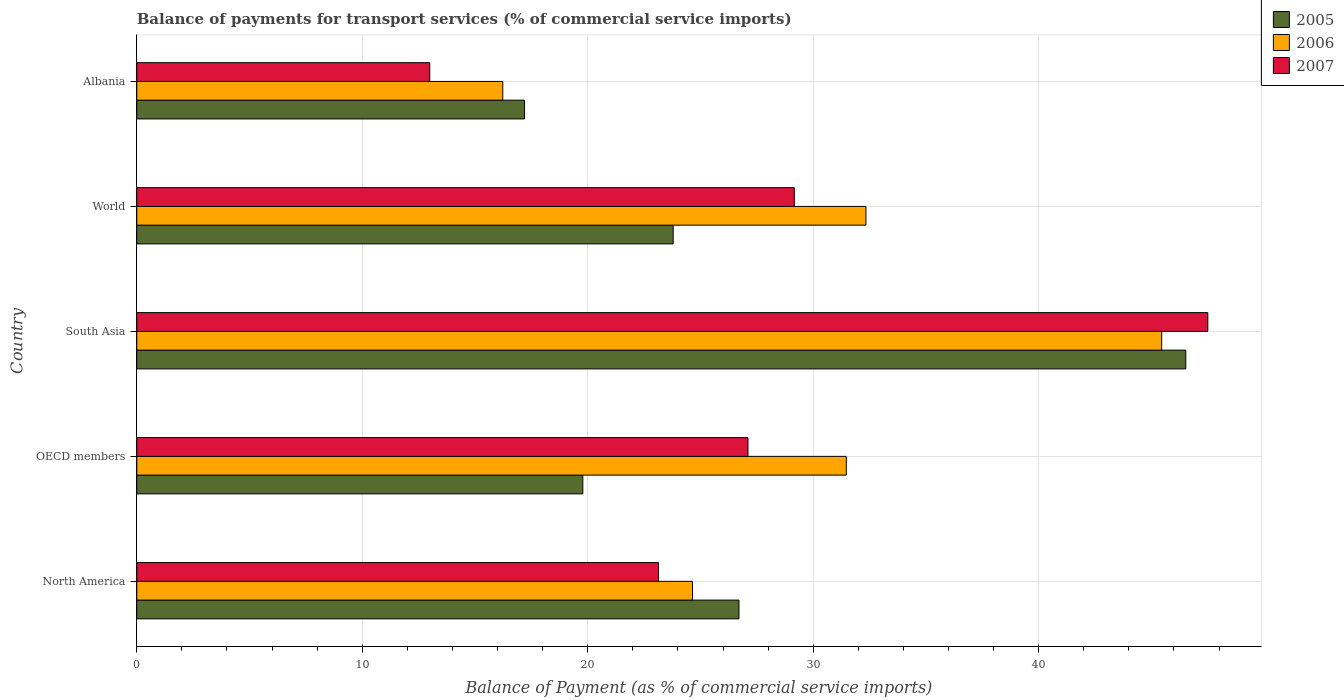How many different coloured bars are there?
Your answer should be very brief. 3. How many groups of bars are there?
Your answer should be compact. 5. Are the number of bars on each tick of the Y-axis equal?
Your answer should be compact. Yes. In how many cases, is the number of bars for a given country not equal to the number of legend labels?
Offer a very short reply. 0. What is the balance of payments for transport services in 2007 in Albania?
Provide a succinct answer. 12.99. Across all countries, what is the maximum balance of payments for transport services in 2007?
Offer a terse response. 47.5. Across all countries, what is the minimum balance of payments for transport services in 2005?
Provide a succinct answer. 17.2. In which country was the balance of payments for transport services in 2005 maximum?
Offer a terse response. South Asia. In which country was the balance of payments for transport services in 2007 minimum?
Provide a succinct answer. Albania. What is the total balance of payments for transport services in 2006 in the graph?
Provide a succinct answer. 150.14. What is the difference between the balance of payments for transport services in 2007 in OECD members and that in South Asia?
Your response must be concise. -20.39. What is the difference between the balance of payments for transport services in 2005 in Albania and the balance of payments for transport services in 2006 in World?
Ensure brevity in your answer.  -15.14. What is the average balance of payments for transport services in 2007 per country?
Provide a short and direct response. 27.98. What is the difference between the balance of payments for transport services in 2007 and balance of payments for transport services in 2005 in World?
Your response must be concise. 5.37. In how many countries, is the balance of payments for transport services in 2006 greater than 32 %?
Ensure brevity in your answer.  2. What is the ratio of the balance of payments for transport services in 2006 in OECD members to that in World?
Make the answer very short. 0.97. Is the difference between the balance of payments for transport services in 2007 in Albania and World greater than the difference between the balance of payments for transport services in 2005 in Albania and World?
Your answer should be compact. No. What is the difference between the highest and the second highest balance of payments for transport services in 2007?
Offer a terse response. 18.34. What is the difference between the highest and the lowest balance of payments for transport services in 2007?
Give a very brief answer. 34.51. Is the sum of the balance of payments for transport services in 2006 in South Asia and World greater than the maximum balance of payments for transport services in 2007 across all countries?
Offer a terse response. Yes. What does the 3rd bar from the bottom in World represents?
Offer a terse response. 2007. Is it the case that in every country, the sum of the balance of payments for transport services in 2006 and balance of payments for transport services in 2007 is greater than the balance of payments for transport services in 2005?
Provide a short and direct response. Yes. Are all the bars in the graph horizontal?
Your answer should be compact. Yes. Are the values on the major ticks of X-axis written in scientific E-notation?
Offer a very short reply. No. Does the graph contain any zero values?
Offer a very short reply. No. Does the graph contain grids?
Offer a very short reply. Yes. How are the legend labels stacked?
Your answer should be very brief. Vertical. What is the title of the graph?
Ensure brevity in your answer.  Balance of payments for transport services (% of commercial service imports). Does "1973" appear as one of the legend labels in the graph?
Your response must be concise. No. What is the label or title of the X-axis?
Keep it short and to the point. Balance of Payment (as % of commercial service imports). What is the Balance of Payment (as % of commercial service imports) in 2005 in North America?
Offer a very short reply. 26.71. What is the Balance of Payment (as % of commercial service imports) of 2006 in North America?
Provide a succinct answer. 24.65. What is the Balance of Payment (as % of commercial service imports) of 2007 in North America?
Your answer should be compact. 23.14. What is the Balance of Payment (as % of commercial service imports) in 2005 in OECD members?
Keep it short and to the point. 19.78. What is the Balance of Payment (as % of commercial service imports) of 2006 in OECD members?
Provide a succinct answer. 31.47. What is the Balance of Payment (as % of commercial service imports) in 2007 in OECD members?
Make the answer very short. 27.11. What is the Balance of Payment (as % of commercial service imports) in 2005 in South Asia?
Offer a terse response. 46.53. What is the Balance of Payment (as % of commercial service imports) in 2006 in South Asia?
Ensure brevity in your answer.  45.46. What is the Balance of Payment (as % of commercial service imports) of 2007 in South Asia?
Ensure brevity in your answer.  47.5. What is the Balance of Payment (as % of commercial service imports) in 2005 in World?
Offer a terse response. 23.79. What is the Balance of Payment (as % of commercial service imports) in 2006 in World?
Your response must be concise. 32.34. What is the Balance of Payment (as % of commercial service imports) of 2007 in World?
Ensure brevity in your answer.  29.16. What is the Balance of Payment (as % of commercial service imports) of 2005 in Albania?
Ensure brevity in your answer.  17.2. What is the Balance of Payment (as % of commercial service imports) in 2006 in Albania?
Offer a very short reply. 16.23. What is the Balance of Payment (as % of commercial service imports) in 2007 in Albania?
Offer a terse response. 12.99. Across all countries, what is the maximum Balance of Payment (as % of commercial service imports) in 2005?
Provide a short and direct response. 46.53. Across all countries, what is the maximum Balance of Payment (as % of commercial service imports) in 2006?
Offer a very short reply. 45.46. Across all countries, what is the maximum Balance of Payment (as % of commercial service imports) in 2007?
Offer a very short reply. 47.5. Across all countries, what is the minimum Balance of Payment (as % of commercial service imports) of 2005?
Your answer should be compact. 17.2. Across all countries, what is the minimum Balance of Payment (as % of commercial service imports) in 2006?
Offer a very short reply. 16.23. Across all countries, what is the minimum Balance of Payment (as % of commercial service imports) of 2007?
Keep it short and to the point. 12.99. What is the total Balance of Payment (as % of commercial service imports) of 2005 in the graph?
Your answer should be compact. 134. What is the total Balance of Payment (as % of commercial service imports) of 2006 in the graph?
Make the answer very short. 150.14. What is the total Balance of Payment (as % of commercial service imports) in 2007 in the graph?
Provide a short and direct response. 139.9. What is the difference between the Balance of Payment (as % of commercial service imports) of 2005 in North America and that in OECD members?
Ensure brevity in your answer.  6.93. What is the difference between the Balance of Payment (as % of commercial service imports) of 2006 in North America and that in OECD members?
Ensure brevity in your answer.  -6.82. What is the difference between the Balance of Payment (as % of commercial service imports) of 2007 in North America and that in OECD members?
Your answer should be very brief. -3.97. What is the difference between the Balance of Payment (as % of commercial service imports) in 2005 in North America and that in South Asia?
Your answer should be compact. -19.82. What is the difference between the Balance of Payment (as % of commercial service imports) in 2006 in North America and that in South Asia?
Provide a short and direct response. -20.81. What is the difference between the Balance of Payment (as % of commercial service imports) of 2007 in North America and that in South Asia?
Provide a succinct answer. -24.36. What is the difference between the Balance of Payment (as % of commercial service imports) in 2005 in North America and that in World?
Give a very brief answer. 2.92. What is the difference between the Balance of Payment (as % of commercial service imports) in 2006 in North America and that in World?
Provide a short and direct response. -7.69. What is the difference between the Balance of Payment (as % of commercial service imports) in 2007 in North America and that in World?
Make the answer very short. -6.02. What is the difference between the Balance of Payment (as % of commercial service imports) of 2005 in North America and that in Albania?
Provide a short and direct response. 9.51. What is the difference between the Balance of Payment (as % of commercial service imports) in 2006 in North America and that in Albania?
Offer a terse response. 8.41. What is the difference between the Balance of Payment (as % of commercial service imports) in 2007 in North America and that in Albania?
Provide a succinct answer. 10.15. What is the difference between the Balance of Payment (as % of commercial service imports) in 2005 in OECD members and that in South Asia?
Provide a short and direct response. -26.74. What is the difference between the Balance of Payment (as % of commercial service imports) in 2006 in OECD members and that in South Asia?
Your answer should be compact. -13.99. What is the difference between the Balance of Payment (as % of commercial service imports) of 2007 in OECD members and that in South Asia?
Keep it short and to the point. -20.39. What is the difference between the Balance of Payment (as % of commercial service imports) in 2005 in OECD members and that in World?
Provide a succinct answer. -4.01. What is the difference between the Balance of Payment (as % of commercial service imports) in 2006 in OECD members and that in World?
Make the answer very short. -0.87. What is the difference between the Balance of Payment (as % of commercial service imports) in 2007 in OECD members and that in World?
Provide a succinct answer. -2.05. What is the difference between the Balance of Payment (as % of commercial service imports) of 2005 in OECD members and that in Albania?
Offer a very short reply. 2.58. What is the difference between the Balance of Payment (as % of commercial service imports) of 2006 in OECD members and that in Albania?
Offer a very short reply. 15.24. What is the difference between the Balance of Payment (as % of commercial service imports) of 2007 in OECD members and that in Albania?
Your answer should be very brief. 14.11. What is the difference between the Balance of Payment (as % of commercial service imports) in 2005 in South Asia and that in World?
Provide a succinct answer. 22.74. What is the difference between the Balance of Payment (as % of commercial service imports) of 2006 in South Asia and that in World?
Keep it short and to the point. 13.12. What is the difference between the Balance of Payment (as % of commercial service imports) of 2007 in South Asia and that in World?
Give a very brief answer. 18.34. What is the difference between the Balance of Payment (as % of commercial service imports) in 2005 in South Asia and that in Albania?
Your answer should be very brief. 29.33. What is the difference between the Balance of Payment (as % of commercial service imports) of 2006 in South Asia and that in Albania?
Give a very brief answer. 29.22. What is the difference between the Balance of Payment (as % of commercial service imports) of 2007 in South Asia and that in Albania?
Your response must be concise. 34.51. What is the difference between the Balance of Payment (as % of commercial service imports) of 2005 in World and that in Albania?
Your response must be concise. 6.59. What is the difference between the Balance of Payment (as % of commercial service imports) of 2006 in World and that in Albania?
Make the answer very short. 16.11. What is the difference between the Balance of Payment (as % of commercial service imports) of 2007 in World and that in Albania?
Give a very brief answer. 16.17. What is the difference between the Balance of Payment (as % of commercial service imports) in 2005 in North America and the Balance of Payment (as % of commercial service imports) in 2006 in OECD members?
Make the answer very short. -4.76. What is the difference between the Balance of Payment (as % of commercial service imports) in 2005 in North America and the Balance of Payment (as % of commercial service imports) in 2007 in OECD members?
Your answer should be compact. -0.4. What is the difference between the Balance of Payment (as % of commercial service imports) of 2006 in North America and the Balance of Payment (as % of commercial service imports) of 2007 in OECD members?
Your answer should be very brief. -2.46. What is the difference between the Balance of Payment (as % of commercial service imports) of 2005 in North America and the Balance of Payment (as % of commercial service imports) of 2006 in South Asia?
Give a very brief answer. -18.75. What is the difference between the Balance of Payment (as % of commercial service imports) of 2005 in North America and the Balance of Payment (as % of commercial service imports) of 2007 in South Asia?
Provide a short and direct response. -20.79. What is the difference between the Balance of Payment (as % of commercial service imports) in 2006 in North America and the Balance of Payment (as % of commercial service imports) in 2007 in South Asia?
Your response must be concise. -22.85. What is the difference between the Balance of Payment (as % of commercial service imports) in 2005 in North America and the Balance of Payment (as % of commercial service imports) in 2006 in World?
Ensure brevity in your answer.  -5.63. What is the difference between the Balance of Payment (as % of commercial service imports) in 2005 in North America and the Balance of Payment (as % of commercial service imports) in 2007 in World?
Offer a very short reply. -2.45. What is the difference between the Balance of Payment (as % of commercial service imports) of 2006 in North America and the Balance of Payment (as % of commercial service imports) of 2007 in World?
Your response must be concise. -4.51. What is the difference between the Balance of Payment (as % of commercial service imports) of 2005 in North America and the Balance of Payment (as % of commercial service imports) of 2006 in Albania?
Make the answer very short. 10.48. What is the difference between the Balance of Payment (as % of commercial service imports) in 2005 in North America and the Balance of Payment (as % of commercial service imports) in 2007 in Albania?
Keep it short and to the point. 13.71. What is the difference between the Balance of Payment (as % of commercial service imports) of 2006 in North America and the Balance of Payment (as % of commercial service imports) of 2007 in Albania?
Provide a succinct answer. 11.65. What is the difference between the Balance of Payment (as % of commercial service imports) in 2005 in OECD members and the Balance of Payment (as % of commercial service imports) in 2006 in South Asia?
Offer a very short reply. -25.67. What is the difference between the Balance of Payment (as % of commercial service imports) of 2005 in OECD members and the Balance of Payment (as % of commercial service imports) of 2007 in South Asia?
Provide a short and direct response. -27.72. What is the difference between the Balance of Payment (as % of commercial service imports) of 2006 in OECD members and the Balance of Payment (as % of commercial service imports) of 2007 in South Asia?
Your answer should be compact. -16.03. What is the difference between the Balance of Payment (as % of commercial service imports) in 2005 in OECD members and the Balance of Payment (as % of commercial service imports) in 2006 in World?
Provide a succinct answer. -12.56. What is the difference between the Balance of Payment (as % of commercial service imports) in 2005 in OECD members and the Balance of Payment (as % of commercial service imports) in 2007 in World?
Make the answer very short. -9.38. What is the difference between the Balance of Payment (as % of commercial service imports) in 2006 in OECD members and the Balance of Payment (as % of commercial service imports) in 2007 in World?
Offer a terse response. 2.31. What is the difference between the Balance of Payment (as % of commercial service imports) of 2005 in OECD members and the Balance of Payment (as % of commercial service imports) of 2006 in Albania?
Your answer should be very brief. 3.55. What is the difference between the Balance of Payment (as % of commercial service imports) of 2005 in OECD members and the Balance of Payment (as % of commercial service imports) of 2007 in Albania?
Your answer should be compact. 6.79. What is the difference between the Balance of Payment (as % of commercial service imports) of 2006 in OECD members and the Balance of Payment (as % of commercial service imports) of 2007 in Albania?
Keep it short and to the point. 18.48. What is the difference between the Balance of Payment (as % of commercial service imports) in 2005 in South Asia and the Balance of Payment (as % of commercial service imports) in 2006 in World?
Provide a succinct answer. 14.19. What is the difference between the Balance of Payment (as % of commercial service imports) of 2005 in South Asia and the Balance of Payment (as % of commercial service imports) of 2007 in World?
Your response must be concise. 17.36. What is the difference between the Balance of Payment (as % of commercial service imports) in 2006 in South Asia and the Balance of Payment (as % of commercial service imports) in 2007 in World?
Offer a very short reply. 16.29. What is the difference between the Balance of Payment (as % of commercial service imports) of 2005 in South Asia and the Balance of Payment (as % of commercial service imports) of 2006 in Albania?
Ensure brevity in your answer.  30.29. What is the difference between the Balance of Payment (as % of commercial service imports) in 2005 in South Asia and the Balance of Payment (as % of commercial service imports) in 2007 in Albania?
Give a very brief answer. 33.53. What is the difference between the Balance of Payment (as % of commercial service imports) in 2006 in South Asia and the Balance of Payment (as % of commercial service imports) in 2007 in Albania?
Offer a terse response. 32.46. What is the difference between the Balance of Payment (as % of commercial service imports) of 2005 in World and the Balance of Payment (as % of commercial service imports) of 2006 in Albania?
Give a very brief answer. 7.56. What is the difference between the Balance of Payment (as % of commercial service imports) in 2005 in World and the Balance of Payment (as % of commercial service imports) in 2007 in Albania?
Offer a terse response. 10.8. What is the difference between the Balance of Payment (as % of commercial service imports) in 2006 in World and the Balance of Payment (as % of commercial service imports) in 2007 in Albania?
Keep it short and to the point. 19.35. What is the average Balance of Payment (as % of commercial service imports) in 2005 per country?
Your answer should be compact. 26.8. What is the average Balance of Payment (as % of commercial service imports) in 2006 per country?
Your answer should be compact. 30.03. What is the average Balance of Payment (as % of commercial service imports) of 2007 per country?
Your response must be concise. 27.98. What is the difference between the Balance of Payment (as % of commercial service imports) of 2005 and Balance of Payment (as % of commercial service imports) of 2006 in North America?
Offer a very short reply. 2.06. What is the difference between the Balance of Payment (as % of commercial service imports) in 2005 and Balance of Payment (as % of commercial service imports) in 2007 in North America?
Your response must be concise. 3.57. What is the difference between the Balance of Payment (as % of commercial service imports) of 2006 and Balance of Payment (as % of commercial service imports) of 2007 in North America?
Give a very brief answer. 1.51. What is the difference between the Balance of Payment (as % of commercial service imports) in 2005 and Balance of Payment (as % of commercial service imports) in 2006 in OECD members?
Give a very brief answer. -11.69. What is the difference between the Balance of Payment (as % of commercial service imports) of 2005 and Balance of Payment (as % of commercial service imports) of 2007 in OECD members?
Offer a very short reply. -7.33. What is the difference between the Balance of Payment (as % of commercial service imports) in 2006 and Balance of Payment (as % of commercial service imports) in 2007 in OECD members?
Keep it short and to the point. 4.36. What is the difference between the Balance of Payment (as % of commercial service imports) in 2005 and Balance of Payment (as % of commercial service imports) in 2006 in South Asia?
Your answer should be very brief. 1.07. What is the difference between the Balance of Payment (as % of commercial service imports) in 2005 and Balance of Payment (as % of commercial service imports) in 2007 in South Asia?
Ensure brevity in your answer.  -0.98. What is the difference between the Balance of Payment (as % of commercial service imports) in 2006 and Balance of Payment (as % of commercial service imports) in 2007 in South Asia?
Offer a very short reply. -2.05. What is the difference between the Balance of Payment (as % of commercial service imports) of 2005 and Balance of Payment (as % of commercial service imports) of 2006 in World?
Offer a terse response. -8.55. What is the difference between the Balance of Payment (as % of commercial service imports) of 2005 and Balance of Payment (as % of commercial service imports) of 2007 in World?
Provide a succinct answer. -5.37. What is the difference between the Balance of Payment (as % of commercial service imports) of 2006 and Balance of Payment (as % of commercial service imports) of 2007 in World?
Your answer should be compact. 3.18. What is the difference between the Balance of Payment (as % of commercial service imports) in 2005 and Balance of Payment (as % of commercial service imports) in 2006 in Albania?
Ensure brevity in your answer.  0.97. What is the difference between the Balance of Payment (as % of commercial service imports) of 2005 and Balance of Payment (as % of commercial service imports) of 2007 in Albania?
Provide a short and direct response. 4.2. What is the difference between the Balance of Payment (as % of commercial service imports) in 2006 and Balance of Payment (as % of commercial service imports) in 2007 in Albania?
Your response must be concise. 3.24. What is the ratio of the Balance of Payment (as % of commercial service imports) in 2005 in North America to that in OECD members?
Your answer should be very brief. 1.35. What is the ratio of the Balance of Payment (as % of commercial service imports) in 2006 in North America to that in OECD members?
Give a very brief answer. 0.78. What is the ratio of the Balance of Payment (as % of commercial service imports) of 2007 in North America to that in OECD members?
Your answer should be very brief. 0.85. What is the ratio of the Balance of Payment (as % of commercial service imports) in 2005 in North America to that in South Asia?
Ensure brevity in your answer.  0.57. What is the ratio of the Balance of Payment (as % of commercial service imports) in 2006 in North America to that in South Asia?
Your answer should be compact. 0.54. What is the ratio of the Balance of Payment (as % of commercial service imports) of 2007 in North America to that in South Asia?
Ensure brevity in your answer.  0.49. What is the ratio of the Balance of Payment (as % of commercial service imports) of 2005 in North America to that in World?
Provide a succinct answer. 1.12. What is the ratio of the Balance of Payment (as % of commercial service imports) of 2006 in North America to that in World?
Offer a very short reply. 0.76. What is the ratio of the Balance of Payment (as % of commercial service imports) in 2007 in North America to that in World?
Offer a terse response. 0.79. What is the ratio of the Balance of Payment (as % of commercial service imports) of 2005 in North America to that in Albania?
Provide a succinct answer. 1.55. What is the ratio of the Balance of Payment (as % of commercial service imports) in 2006 in North America to that in Albania?
Your answer should be compact. 1.52. What is the ratio of the Balance of Payment (as % of commercial service imports) in 2007 in North America to that in Albania?
Keep it short and to the point. 1.78. What is the ratio of the Balance of Payment (as % of commercial service imports) of 2005 in OECD members to that in South Asia?
Offer a very short reply. 0.43. What is the ratio of the Balance of Payment (as % of commercial service imports) in 2006 in OECD members to that in South Asia?
Make the answer very short. 0.69. What is the ratio of the Balance of Payment (as % of commercial service imports) in 2007 in OECD members to that in South Asia?
Keep it short and to the point. 0.57. What is the ratio of the Balance of Payment (as % of commercial service imports) in 2005 in OECD members to that in World?
Give a very brief answer. 0.83. What is the ratio of the Balance of Payment (as % of commercial service imports) of 2006 in OECD members to that in World?
Make the answer very short. 0.97. What is the ratio of the Balance of Payment (as % of commercial service imports) in 2007 in OECD members to that in World?
Your answer should be compact. 0.93. What is the ratio of the Balance of Payment (as % of commercial service imports) of 2005 in OECD members to that in Albania?
Ensure brevity in your answer.  1.15. What is the ratio of the Balance of Payment (as % of commercial service imports) in 2006 in OECD members to that in Albania?
Ensure brevity in your answer.  1.94. What is the ratio of the Balance of Payment (as % of commercial service imports) in 2007 in OECD members to that in Albania?
Provide a succinct answer. 2.09. What is the ratio of the Balance of Payment (as % of commercial service imports) in 2005 in South Asia to that in World?
Provide a succinct answer. 1.96. What is the ratio of the Balance of Payment (as % of commercial service imports) in 2006 in South Asia to that in World?
Offer a very short reply. 1.41. What is the ratio of the Balance of Payment (as % of commercial service imports) of 2007 in South Asia to that in World?
Offer a terse response. 1.63. What is the ratio of the Balance of Payment (as % of commercial service imports) of 2005 in South Asia to that in Albania?
Your response must be concise. 2.71. What is the ratio of the Balance of Payment (as % of commercial service imports) in 2006 in South Asia to that in Albania?
Keep it short and to the point. 2.8. What is the ratio of the Balance of Payment (as % of commercial service imports) of 2007 in South Asia to that in Albania?
Your answer should be very brief. 3.66. What is the ratio of the Balance of Payment (as % of commercial service imports) of 2005 in World to that in Albania?
Your response must be concise. 1.38. What is the ratio of the Balance of Payment (as % of commercial service imports) in 2006 in World to that in Albania?
Offer a very short reply. 1.99. What is the ratio of the Balance of Payment (as % of commercial service imports) of 2007 in World to that in Albania?
Provide a short and direct response. 2.24. What is the difference between the highest and the second highest Balance of Payment (as % of commercial service imports) of 2005?
Offer a terse response. 19.82. What is the difference between the highest and the second highest Balance of Payment (as % of commercial service imports) of 2006?
Your answer should be compact. 13.12. What is the difference between the highest and the second highest Balance of Payment (as % of commercial service imports) of 2007?
Offer a very short reply. 18.34. What is the difference between the highest and the lowest Balance of Payment (as % of commercial service imports) of 2005?
Your answer should be compact. 29.33. What is the difference between the highest and the lowest Balance of Payment (as % of commercial service imports) in 2006?
Ensure brevity in your answer.  29.22. What is the difference between the highest and the lowest Balance of Payment (as % of commercial service imports) in 2007?
Give a very brief answer. 34.51. 